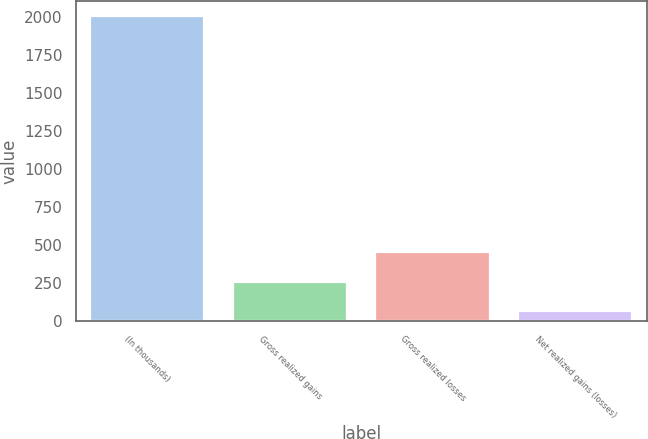Convert chart to OTSL. <chart><loc_0><loc_0><loc_500><loc_500><bar_chart><fcel>(In thousands)<fcel>Gross realized gains<fcel>Gross realized losses<fcel>Net realized gains (losses)<nl><fcel>2007<fcel>260.1<fcel>454.2<fcel>66<nl></chart> 